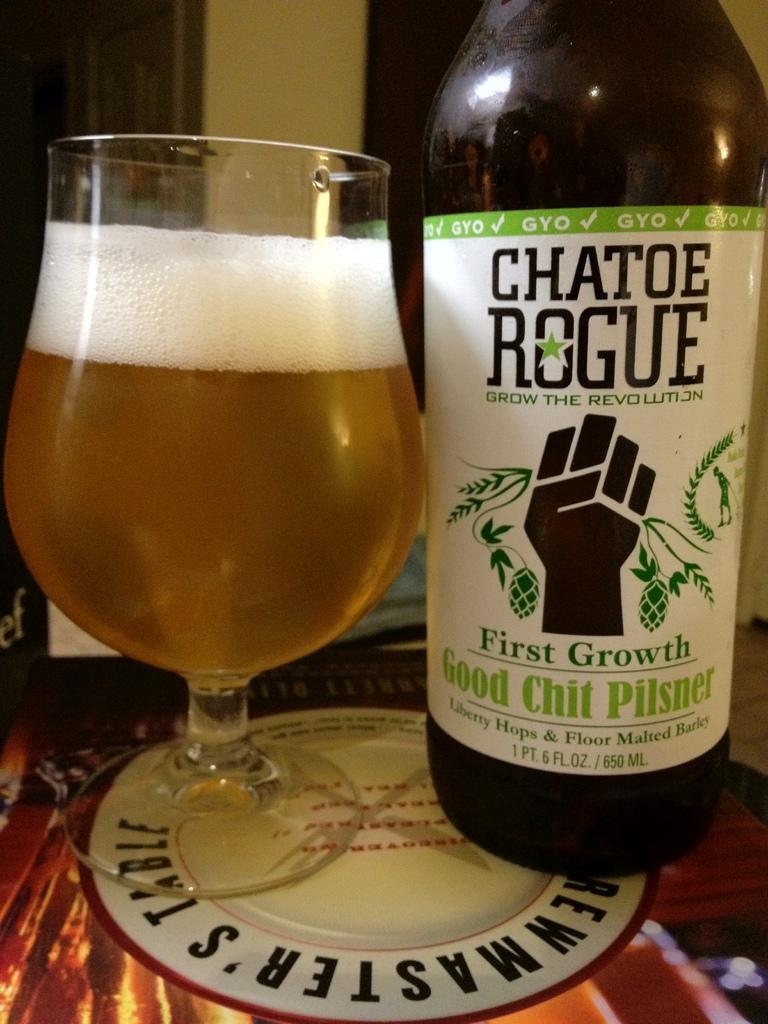<image>
Share a concise interpretation of the image provided. A bottle with a label that reads Chatoe Rogue. 